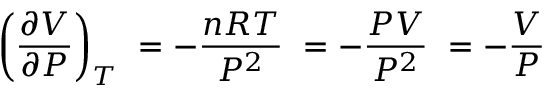Convert formula to latex. <formula><loc_0><loc_0><loc_500><loc_500>\left ( { \frac { \partial V } { \partial P } } \right ) _ { T } \ = - { \frac { n R T } { P ^ { 2 } } } \ = - { \frac { P V } { P ^ { 2 } } } \ = - { \frac { V } { P } }</formula> 